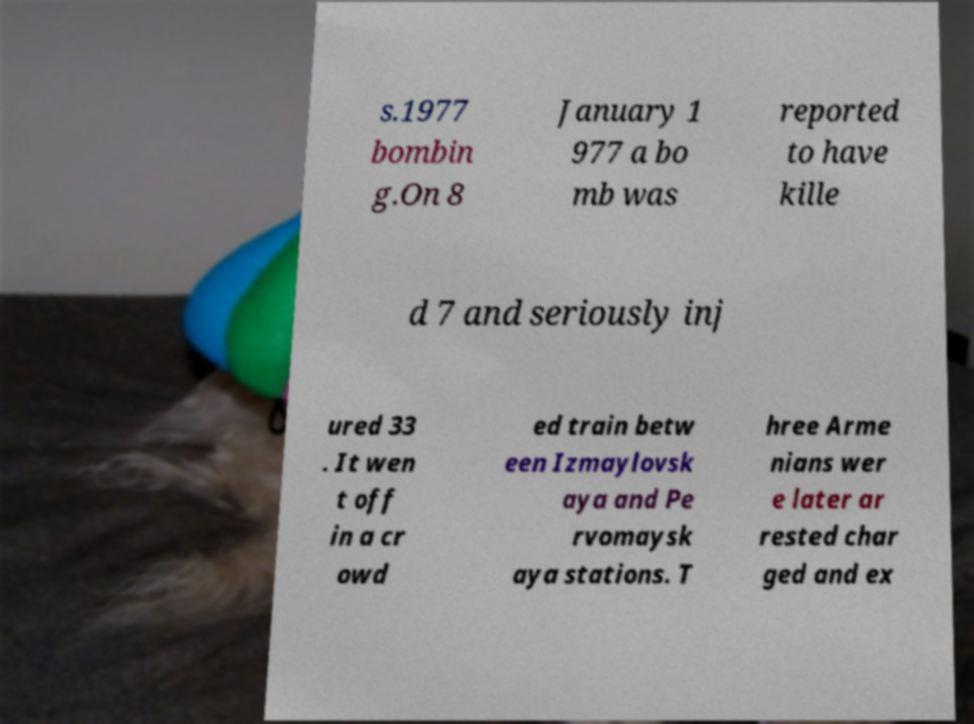What messages or text are displayed in this image? I need them in a readable, typed format. s.1977 bombin g.On 8 January 1 977 a bo mb was reported to have kille d 7 and seriously inj ured 33 . It wen t off in a cr owd ed train betw een Izmaylovsk aya and Pe rvomaysk aya stations. T hree Arme nians wer e later ar rested char ged and ex 